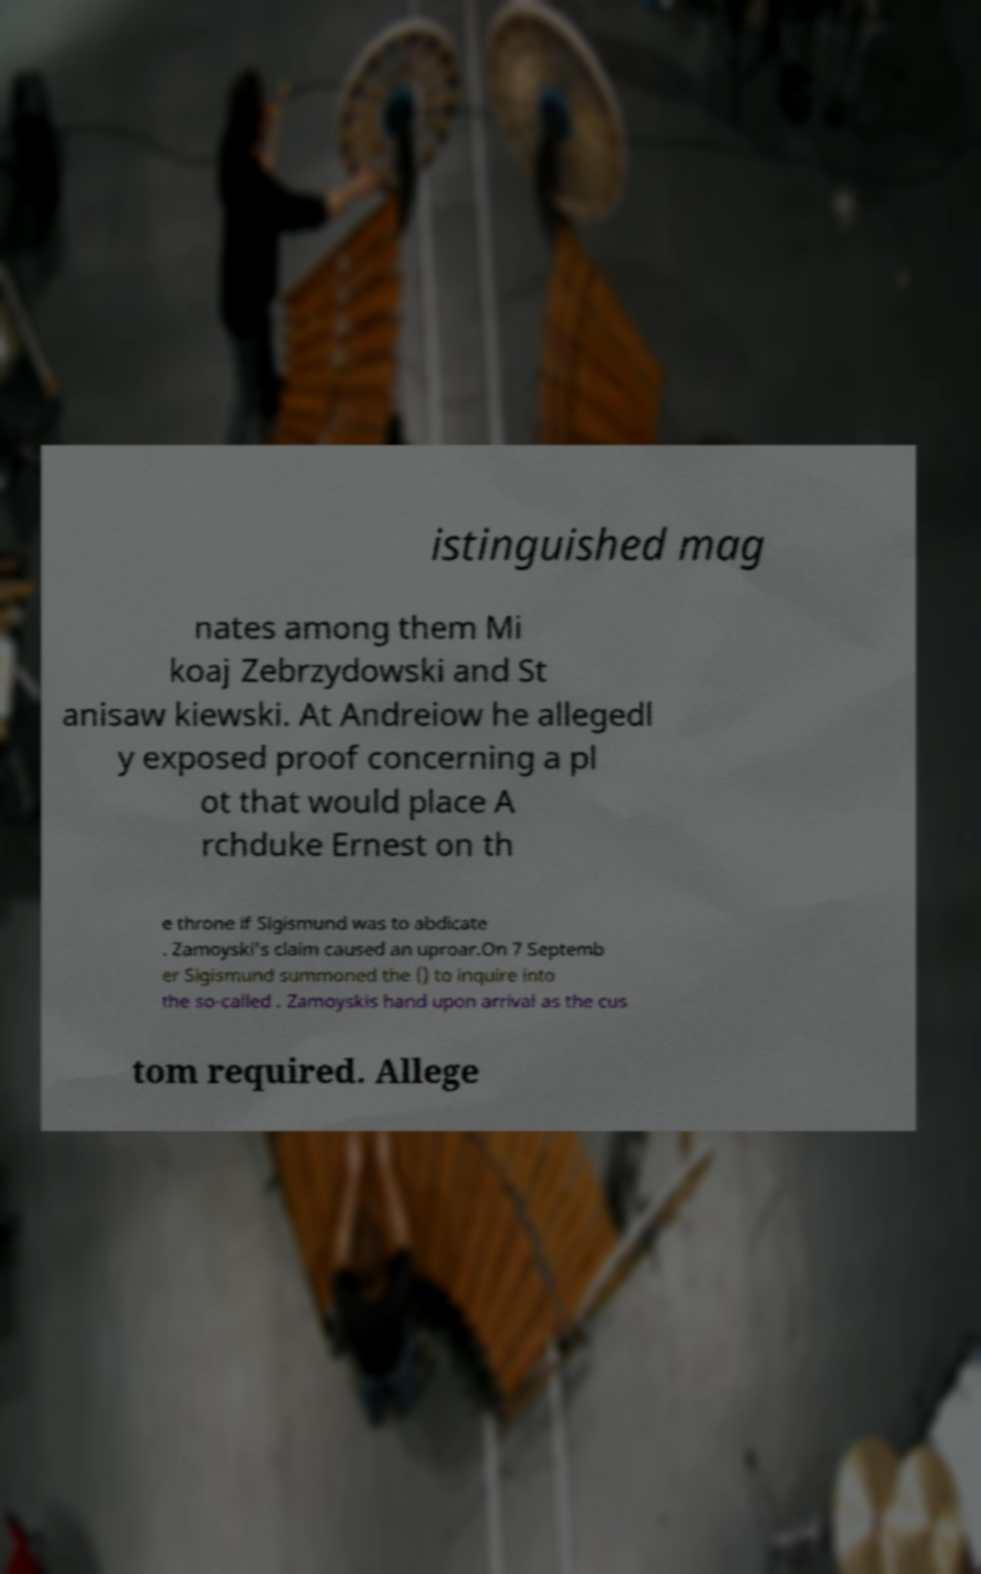I need the written content from this picture converted into text. Can you do that? istinguished mag nates among them Mi koaj Zebrzydowski and St anisaw kiewski. At Andreiow he allegedl y exposed proof concerning a pl ot that would place A rchduke Ernest on th e throne if Sigismund was to abdicate . Zamoyski's claim caused an uproar.On 7 Septemb er Sigismund summoned the () to inquire into the so-called . Zamoyskis hand upon arrival as the cus tom required. Allege 